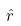Convert formula to latex. <formula><loc_0><loc_0><loc_500><loc_500>\hat { r }</formula> 